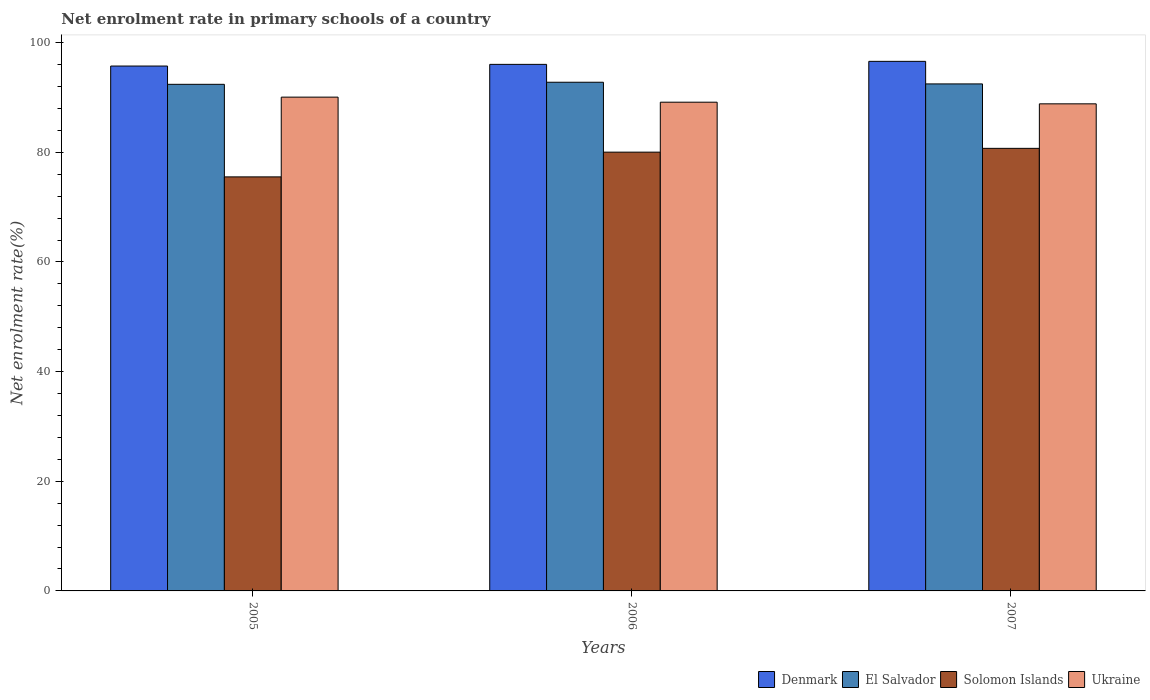Are the number of bars per tick equal to the number of legend labels?
Offer a very short reply. Yes. Are the number of bars on each tick of the X-axis equal?
Offer a terse response. Yes. How many bars are there on the 3rd tick from the left?
Offer a terse response. 4. In how many cases, is the number of bars for a given year not equal to the number of legend labels?
Provide a succinct answer. 0. What is the net enrolment rate in primary schools in El Salvador in 2006?
Your response must be concise. 92.79. Across all years, what is the maximum net enrolment rate in primary schools in Solomon Islands?
Provide a short and direct response. 80.73. Across all years, what is the minimum net enrolment rate in primary schools in El Salvador?
Make the answer very short. 92.41. In which year was the net enrolment rate in primary schools in Ukraine maximum?
Your answer should be very brief. 2005. In which year was the net enrolment rate in primary schools in Ukraine minimum?
Provide a short and direct response. 2007. What is the total net enrolment rate in primary schools in El Salvador in the graph?
Your response must be concise. 277.68. What is the difference between the net enrolment rate in primary schools in Ukraine in 2006 and that in 2007?
Your response must be concise. 0.3. What is the difference between the net enrolment rate in primary schools in Denmark in 2007 and the net enrolment rate in primary schools in Ukraine in 2006?
Offer a terse response. 7.45. What is the average net enrolment rate in primary schools in Ukraine per year?
Your answer should be compact. 89.36. In the year 2007, what is the difference between the net enrolment rate in primary schools in Solomon Islands and net enrolment rate in primary schools in El Salvador?
Offer a terse response. -11.76. What is the ratio of the net enrolment rate in primary schools in El Salvador in 2005 to that in 2007?
Provide a succinct answer. 1. Is the net enrolment rate in primary schools in Solomon Islands in 2005 less than that in 2006?
Keep it short and to the point. Yes. What is the difference between the highest and the second highest net enrolment rate in primary schools in Ukraine?
Your answer should be very brief. 0.92. What is the difference between the highest and the lowest net enrolment rate in primary schools in Solomon Islands?
Your response must be concise. 5.2. Is the sum of the net enrolment rate in primary schools in Solomon Islands in 2006 and 2007 greater than the maximum net enrolment rate in primary schools in El Salvador across all years?
Your answer should be compact. Yes. What does the 4th bar from the left in 2007 represents?
Keep it short and to the point. Ukraine. How many years are there in the graph?
Offer a terse response. 3. What is the difference between two consecutive major ticks on the Y-axis?
Make the answer very short. 20. Does the graph contain any zero values?
Make the answer very short. No. Where does the legend appear in the graph?
Give a very brief answer. Bottom right. How many legend labels are there?
Give a very brief answer. 4. How are the legend labels stacked?
Offer a very short reply. Horizontal. What is the title of the graph?
Offer a terse response. Net enrolment rate in primary schools of a country. Does "Cayman Islands" appear as one of the legend labels in the graph?
Offer a very short reply. No. What is the label or title of the X-axis?
Provide a short and direct response. Years. What is the label or title of the Y-axis?
Your answer should be compact. Net enrolment rate(%). What is the Net enrolment rate(%) in Denmark in 2005?
Your response must be concise. 95.74. What is the Net enrolment rate(%) of El Salvador in 2005?
Offer a terse response. 92.41. What is the Net enrolment rate(%) of Solomon Islands in 2005?
Make the answer very short. 75.52. What is the Net enrolment rate(%) in Ukraine in 2005?
Ensure brevity in your answer.  90.07. What is the Net enrolment rate(%) in Denmark in 2006?
Your answer should be very brief. 96.05. What is the Net enrolment rate(%) in El Salvador in 2006?
Give a very brief answer. 92.79. What is the Net enrolment rate(%) of Solomon Islands in 2006?
Your response must be concise. 80.04. What is the Net enrolment rate(%) in Ukraine in 2006?
Offer a very short reply. 89.15. What is the Net enrolment rate(%) of Denmark in 2007?
Your answer should be compact. 96.6. What is the Net enrolment rate(%) in El Salvador in 2007?
Provide a succinct answer. 92.48. What is the Net enrolment rate(%) of Solomon Islands in 2007?
Give a very brief answer. 80.73. What is the Net enrolment rate(%) in Ukraine in 2007?
Provide a short and direct response. 88.85. Across all years, what is the maximum Net enrolment rate(%) of Denmark?
Keep it short and to the point. 96.6. Across all years, what is the maximum Net enrolment rate(%) in El Salvador?
Your response must be concise. 92.79. Across all years, what is the maximum Net enrolment rate(%) of Solomon Islands?
Your response must be concise. 80.73. Across all years, what is the maximum Net enrolment rate(%) in Ukraine?
Offer a very short reply. 90.07. Across all years, what is the minimum Net enrolment rate(%) in Denmark?
Make the answer very short. 95.74. Across all years, what is the minimum Net enrolment rate(%) in El Salvador?
Provide a short and direct response. 92.41. Across all years, what is the minimum Net enrolment rate(%) in Solomon Islands?
Keep it short and to the point. 75.52. Across all years, what is the minimum Net enrolment rate(%) of Ukraine?
Provide a succinct answer. 88.85. What is the total Net enrolment rate(%) in Denmark in the graph?
Make the answer very short. 288.39. What is the total Net enrolment rate(%) in El Salvador in the graph?
Give a very brief answer. 277.68. What is the total Net enrolment rate(%) of Solomon Islands in the graph?
Give a very brief answer. 236.29. What is the total Net enrolment rate(%) in Ukraine in the graph?
Your answer should be compact. 268.07. What is the difference between the Net enrolment rate(%) of Denmark in 2005 and that in 2006?
Give a very brief answer. -0.3. What is the difference between the Net enrolment rate(%) in El Salvador in 2005 and that in 2006?
Give a very brief answer. -0.38. What is the difference between the Net enrolment rate(%) of Solomon Islands in 2005 and that in 2006?
Ensure brevity in your answer.  -4.51. What is the difference between the Net enrolment rate(%) of Ukraine in 2005 and that in 2006?
Offer a terse response. 0.92. What is the difference between the Net enrolment rate(%) of Denmark in 2005 and that in 2007?
Your answer should be compact. -0.85. What is the difference between the Net enrolment rate(%) of El Salvador in 2005 and that in 2007?
Your answer should be compact. -0.07. What is the difference between the Net enrolment rate(%) in Solomon Islands in 2005 and that in 2007?
Give a very brief answer. -5.2. What is the difference between the Net enrolment rate(%) in Ukraine in 2005 and that in 2007?
Ensure brevity in your answer.  1.22. What is the difference between the Net enrolment rate(%) in Denmark in 2006 and that in 2007?
Keep it short and to the point. -0.55. What is the difference between the Net enrolment rate(%) of El Salvador in 2006 and that in 2007?
Your answer should be very brief. 0.31. What is the difference between the Net enrolment rate(%) in Solomon Islands in 2006 and that in 2007?
Ensure brevity in your answer.  -0.69. What is the difference between the Net enrolment rate(%) of Ukraine in 2006 and that in 2007?
Give a very brief answer. 0.3. What is the difference between the Net enrolment rate(%) of Denmark in 2005 and the Net enrolment rate(%) of El Salvador in 2006?
Give a very brief answer. 2.96. What is the difference between the Net enrolment rate(%) of Denmark in 2005 and the Net enrolment rate(%) of Solomon Islands in 2006?
Provide a short and direct response. 15.71. What is the difference between the Net enrolment rate(%) in Denmark in 2005 and the Net enrolment rate(%) in Ukraine in 2006?
Ensure brevity in your answer.  6.6. What is the difference between the Net enrolment rate(%) of El Salvador in 2005 and the Net enrolment rate(%) of Solomon Islands in 2006?
Make the answer very short. 12.37. What is the difference between the Net enrolment rate(%) of El Salvador in 2005 and the Net enrolment rate(%) of Ukraine in 2006?
Keep it short and to the point. 3.26. What is the difference between the Net enrolment rate(%) of Solomon Islands in 2005 and the Net enrolment rate(%) of Ukraine in 2006?
Ensure brevity in your answer.  -13.62. What is the difference between the Net enrolment rate(%) of Denmark in 2005 and the Net enrolment rate(%) of El Salvador in 2007?
Make the answer very short. 3.26. What is the difference between the Net enrolment rate(%) in Denmark in 2005 and the Net enrolment rate(%) in Solomon Islands in 2007?
Your answer should be compact. 15.02. What is the difference between the Net enrolment rate(%) in Denmark in 2005 and the Net enrolment rate(%) in Ukraine in 2007?
Keep it short and to the point. 6.9. What is the difference between the Net enrolment rate(%) in El Salvador in 2005 and the Net enrolment rate(%) in Solomon Islands in 2007?
Make the answer very short. 11.68. What is the difference between the Net enrolment rate(%) of El Salvador in 2005 and the Net enrolment rate(%) of Ukraine in 2007?
Give a very brief answer. 3.56. What is the difference between the Net enrolment rate(%) in Solomon Islands in 2005 and the Net enrolment rate(%) in Ukraine in 2007?
Provide a succinct answer. -13.32. What is the difference between the Net enrolment rate(%) of Denmark in 2006 and the Net enrolment rate(%) of El Salvador in 2007?
Give a very brief answer. 3.56. What is the difference between the Net enrolment rate(%) of Denmark in 2006 and the Net enrolment rate(%) of Solomon Islands in 2007?
Your answer should be compact. 15.32. What is the difference between the Net enrolment rate(%) in Denmark in 2006 and the Net enrolment rate(%) in Ukraine in 2007?
Offer a terse response. 7.2. What is the difference between the Net enrolment rate(%) of El Salvador in 2006 and the Net enrolment rate(%) of Solomon Islands in 2007?
Keep it short and to the point. 12.06. What is the difference between the Net enrolment rate(%) in El Salvador in 2006 and the Net enrolment rate(%) in Ukraine in 2007?
Offer a terse response. 3.94. What is the difference between the Net enrolment rate(%) of Solomon Islands in 2006 and the Net enrolment rate(%) of Ukraine in 2007?
Your answer should be very brief. -8.81. What is the average Net enrolment rate(%) in Denmark per year?
Your answer should be compact. 96.13. What is the average Net enrolment rate(%) of El Salvador per year?
Provide a short and direct response. 92.56. What is the average Net enrolment rate(%) of Solomon Islands per year?
Your answer should be very brief. 78.76. What is the average Net enrolment rate(%) of Ukraine per year?
Offer a terse response. 89.36. In the year 2005, what is the difference between the Net enrolment rate(%) of Denmark and Net enrolment rate(%) of El Salvador?
Offer a very short reply. 3.33. In the year 2005, what is the difference between the Net enrolment rate(%) of Denmark and Net enrolment rate(%) of Solomon Islands?
Offer a very short reply. 20.22. In the year 2005, what is the difference between the Net enrolment rate(%) of Denmark and Net enrolment rate(%) of Ukraine?
Offer a very short reply. 5.67. In the year 2005, what is the difference between the Net enrolment rate(%) of El Salvador and Net enrolment rate(%) of Solomon Islands?
Provide a short and direct response. 16.89. In the year 2005, what is the difference between the Net enrolment rate(%) of El Salvador and Net enrolment rate(%) of Ukraine?
Provide a succinct answer. 2.34. In the year 2005, what is the difference between the Net enrolment rate(%) in Solomon Islands and Net enrolment rate(%) in Ukraine?
Your response must be concise. -14.55. In the year 2006, what is the difference between the Net enrolment rate(%) of Denmark and Net enrolment rate(%) of El Salvador?
Offer a very short reply. 3.26. In the year 2006, what is the difference between the Net enrolment rate(%) of Denmark and Net enrolment rate(%) of Solomon Islands?
Your response must be concise. 16.01. In the year 2006, what is the difference between the Net enrolment rate(%) in Denmark and Net enrolment rate(%) in Ukraine?
Give a very brief answer. 6.9. In the year 2006, what is the difference between the Net enrolment rate(%) in El Salvador and Net enrolment rate(%) in Solomon Islands?
Give a very brief answer. 12.75. In the year 2006, what is the difference between the Net enrolment rate(%) of El Salvador and Net enrolment rate(%) of Ukraine?
Keep it short and to the point. 3.64. In the year 2006, what is the difference between the Net enrolment rate(%) in Solomon Islands and Net enrolment rate(%) in Ukraine?
Your answer should be very brief. -9.11. In the year 2007, what is the difference between the Net enrolment rate(%) of Denmark and Net enrolment rate(%) of El Salvador?
Ensure brevity in your answer.  4.11. In the year 2007, what is the difference between the Net enrolment rate(%) of Denmark and Net enrolment rate(%) of Solomon Islands?
Provide a succinct answer. 15.87. In the year 2007, what is the difference between the Net enrolment rate(%) of Denmark and Net enrolment rate(%) of Ukraine?
Keep it short and to the point. 7.75. In the year 2007, what is the difference between the Net enrolment rate(%) in El Salvador and Net enrolment rate(%) in Solomon Islands?
Give a very brief answer. 11.76. In the year 2007, what is the difference between the Net enrolment rate(%) in El Salvador and Net enrolment rate(%) in Ukraine?
Keep it short and to the point. 3.63. In the year 2007, what is the difference between the Net enrolment rate(%) in Solomon Islands and Net enrolment rate(%) in Ukraine?
Make the answer very short. -8.12. What is the ratio of the Net enrolment rate(%) in Denmark in 2005 to that in 2006?
Keep it short and to the point. 1. What is the ratio of the Net enrolment rate(%) in Solomon Islands in 2005 to that in 2006?
Your answer should be very brief. 0.94. What is the ratio of the Net enrolment rate(%) of Ukraine in 2005 to that in 2006?
Your answer should be compact. 1.01. What is the ratio of the Net enrolment rate(%) in Solomon Islands in 2005 to that in 2007?
Your answer should be compact. 0.94. What is the ratio of the Net enrolment rate(%) of Ukraine in 2005 to that in 2007?
Keep it short and to the point. 1.01. What is the ratio of the Net enrolment rate(%) in Solomon Islands in 2006 to that in 2007?
Give a very brief answer. 0.99. What is the difference between the highest and the second highest Net enrolment rate(%) of Denmark?
Your answer should be compact. 0.55. What is the difference between the highest and the second highest Net enrolment rate(%) in El Salvador?
Provide a succinct answer. 0.31. What is the difference between the highest and the second highest Net enrolment rate(%) in Solomon Islands?
Offer a terse response. 0.69. What is the difference between the highest and the second highest Net enrolment rate(%) of Ukraine?
Keep it short and to the point. 0.92. What is the difference between the highest and the lowest Net enrolment rate(%) in Denmark?
Provide a succinct answer. 0.85. What is the difference between the highest and the lowest Net enrolment rate(%) of El Salvador?
Your answer should be very brief. 0.38. What is the difference between the highest and the lowest Net enrolment rate(%) of Solomon Islands?
Provide a short and direct response. 5.2. What is the difference between the highest and the lowest Net enrolment rate(%) in Ukraine?
Your response must be concise. 1.22. 